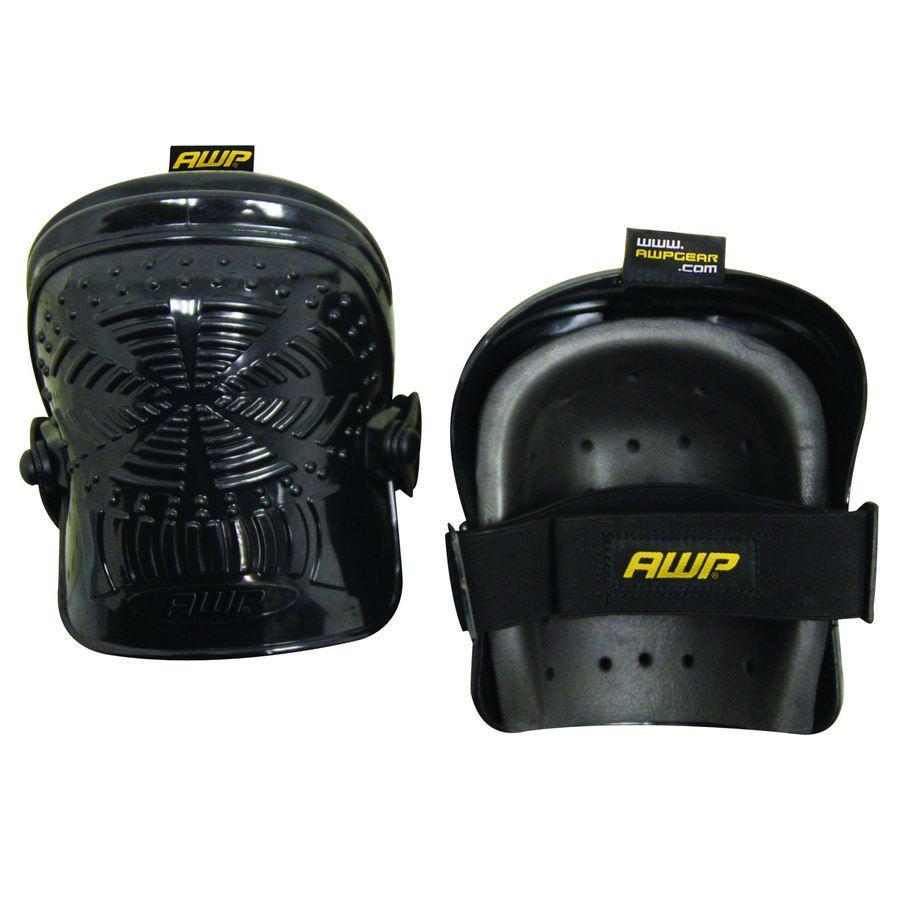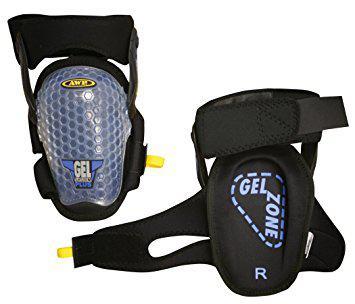The first image is the image on the left, the second image is the image on the right. For the images shown, is this caption "At least one knee pad tells you which knee to put it on." true? Answer yes or no. Yes. The first image is the image on the left, the second image is the image on the right. Assess this claim about the two images: "In the image on the right, you can clearly see the label that designates which knee this pad goes on.". Correct or not? Answer yes or no. Yes. 